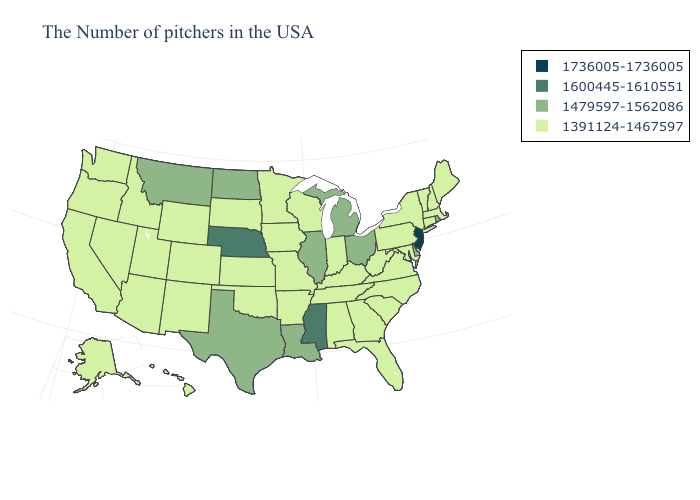Which states have the highest value in the USA?
Answer briefly. New Jersey. What is the value of Alabama?
Be succinct. 1391124-1467597. What is the highest value in states that border Arizona?
Answer briefly. 1391124-1467597. Does New Jersey have the highest value in the Northeast?
Answer briefly. Yes. What is the value of Colorado?
Short answer required. 1391124-1467597. Among the states that border Indiana , which have the lowest value?
Keep it brief. Kentucky. Name the states that have a value in the range 1736005-1736005?
Quick response, please. New Jersey. Does South Carolina have a lower value than Mississippi?
Keep it brief. Yes. Name the states that have a value in the range 1600445-1610551?
Concise answer only. Mississippi, Nebraska. Which states hav the highest value in the Northeast?
Concise answer only. New Jersey. Which states have the lowest value in the USA?
Concise answer only. Maine, Massachusetts, New Hampshire, Vermont, Connecticut, New York, Maryland, Pennsylvania, Virginia, North Carolina, South Carolina, West Virginia, Florida, Georgia, Kentucky, Indiana, Alabama, Tennessee, Wisconsin, Missouri, Arkansas, Minnesota, Iowa, Kansas, Oklahoma, South Dakota, Wyoming, Colorado, New Mexico, Utah, Arizona, Idaho, Nevada, California, Washington, Oregon, Alaska, Hawaii. Name the states that have a value in the range 1736005-1736005?
Short answer required. New Jersey. Name the states that have a value in the range 1479597-1562086?
Give a very brief answer. Rhode Island, Delaware, Ohio, Michigan, Illinois, Louisiana, Texas, North Dakota, Montana. What is the value of Wyoming?
Be succinct. 1391124-1467597. Name the states that have a value in the range 1600445-1610551?
Short answer required. Mississippi, Nebraska. 